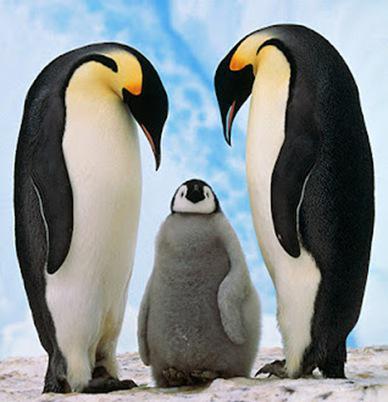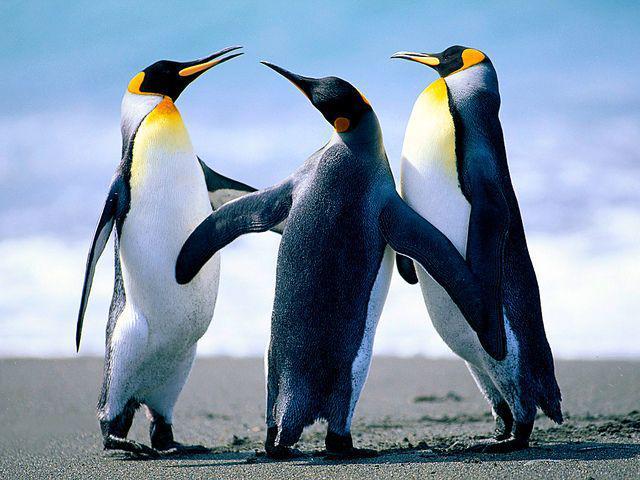The first image is the image on the left, the second image is the image on the right. For the images displayed, is the sentence "there is only one penguin on the right image" factually correct? Answer yes or no. No. 